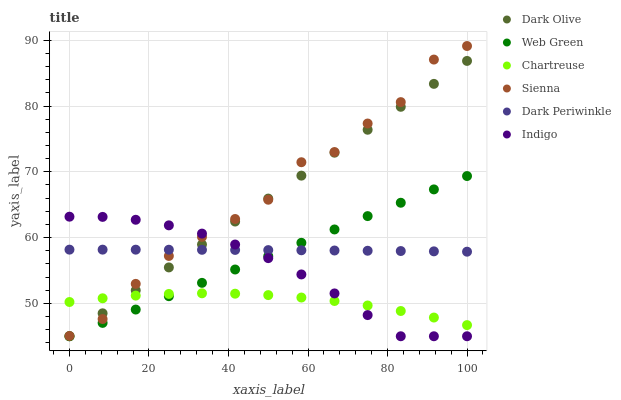Does Chartreuse have the minimum area under the curve?
Answer yes or no. Yes. Does Sienna have the maximum area under the curve?
Answer yes or no. Yes. Does Dark Olive have the minimum area under the curve?
Answer yes or no. No. Does Dark Olive have the maximum area under the curve?
Answer yes or no. No. Is Web Green the smoothest?
Answer yes or no. Yes. Is Sienna the roughest?
Answer yes or no. Yes. Is Dark Olive the smoothest?
Answer yes or no. No. Is Dark Olive the roughest?
Answer yes or no. No. Does Indigo have the lowest value?
Answer yes or no. Yes. Does Sienna have the lowest value?
Answer yes or no. No. Does Sienna have the highest value?
Answer yes or no. Yes. Does Dark Olive have the highest value?
Answer yes or no. No. Is Web Green less than Sienna?
Answer yes or no. Yes. Is Dark Periwinkle greater than Chartreuse?
Answer yes or no. Yes. Does Web Green intersect Dark Olive?
Answer yes or no. Yes. Is Web Green less than Dark Olive?
Answer yes or no. No. Is Web Green greater than Dark Olive?
Answer yes or no. No. Does Web Green intersect Sienna?
Answer yes or no. No. 